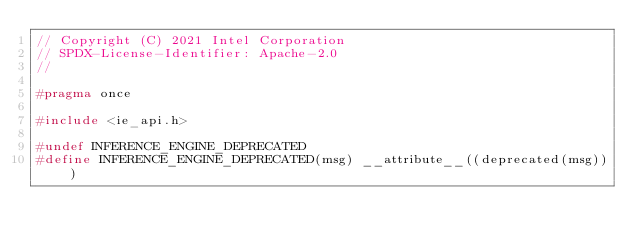<code> <loc_0><loc_0><loc_500><loc_500><_C++_>// Copyright (C) 2021 Intel Corporation
// SPDX-License-Identifier: Apache-2.0
//

#pragma once

#include <ie_api.h>

#undef INFERENCE_ENGINE_DEPRECATED
#define INFERENCE_ENGINE_DEPRECATED(msg) __attribute__((deprecated(msg)))
</code> 